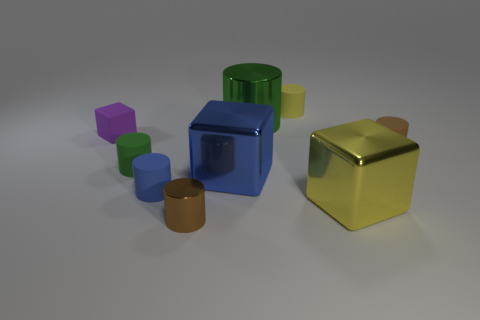Subtract all brown cylinders. How many cylinders are left? 4 Subtract 1 cylinders. How many cylinders are left? 5 Subtract all large cylinders. How many cylinders are left? 5 Subtract all gray cylinders. Subtract all blue balls. How many cylinders are left? 6 Add 1 blue matte objects. How many objects exist? 10 Subtract all cubes. How many objects are left? 6 Subtract all big yellow metal things. Subtract all small purple cubes. How many objects are left? 7 Add 2 tiny brown shiny things. How many tiny brown shiny things are left? 3 Add 2 large green metal cylinders. How many large green metal cylinders exist? 3 Subtract 0 brown balls. How many objects are left? 9 